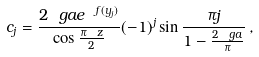<formula> <loc_0><loc_0><loc_500><loc_500>c _ { j } = \frac { 2 \ g a e ^ { \ f ( y _ { j } ) } } { \cos \frac { \pi \ z } { 2 } } ( - 1 ) ^ { j } \sin \frac { \pi j } { 1 - \frac { 2 \ g a } { \pi } } \, ,</formula> 